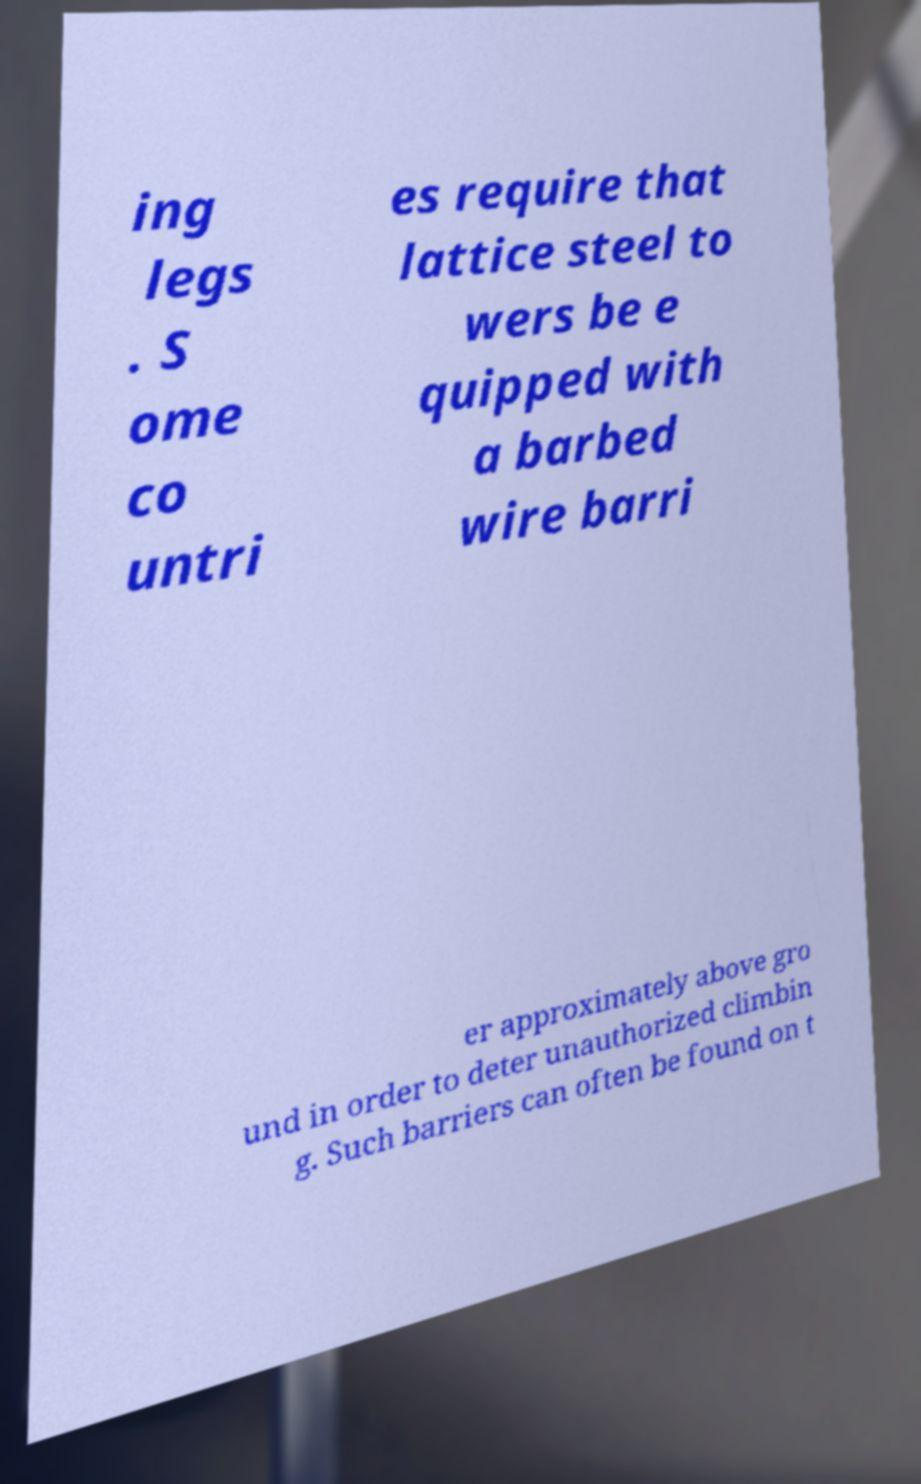Please identify and transcribe the text found in this image. ing legs . S ome co untri es require that lattice steel to wers be e quipped with a barbed wire barri er approximately above gro und in order to deter unauthorized climbin g. Such barriers can often be found on t 